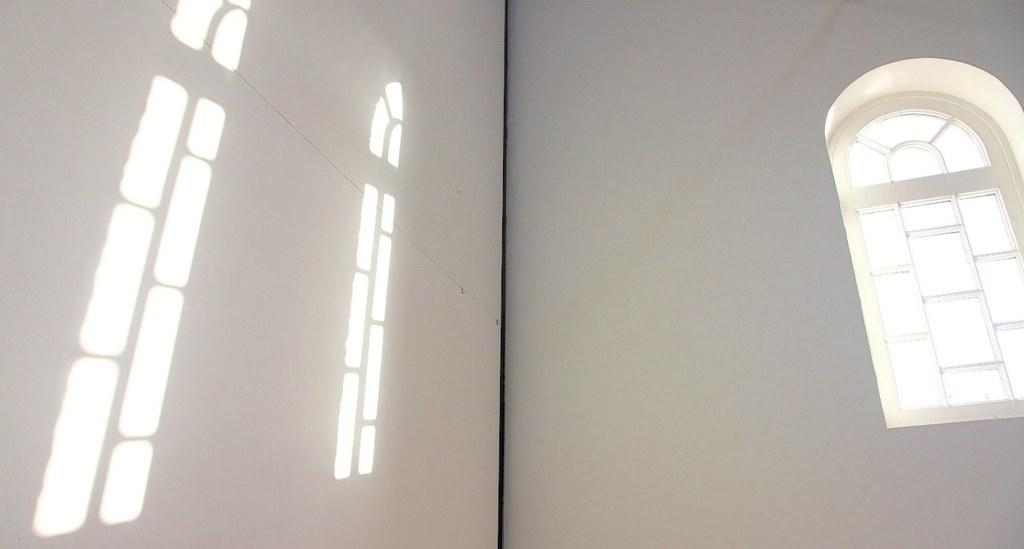What is located on the right side of the image? There is a window on the right side of the image. What color is the wall visible in the image? The wall in the image is white. What can be seen on the left side of the image? Sunlight is visible on the left side of the image. Are there any popcorn kernels visible on the white wall in the image? There is no mention of popcorn kernels in the provided facts, so we cannot definitively answer that question. Can you see any ghosts in the image? There is no mention of ghosts in the provided facts, so we cannot definitively answer that question. 